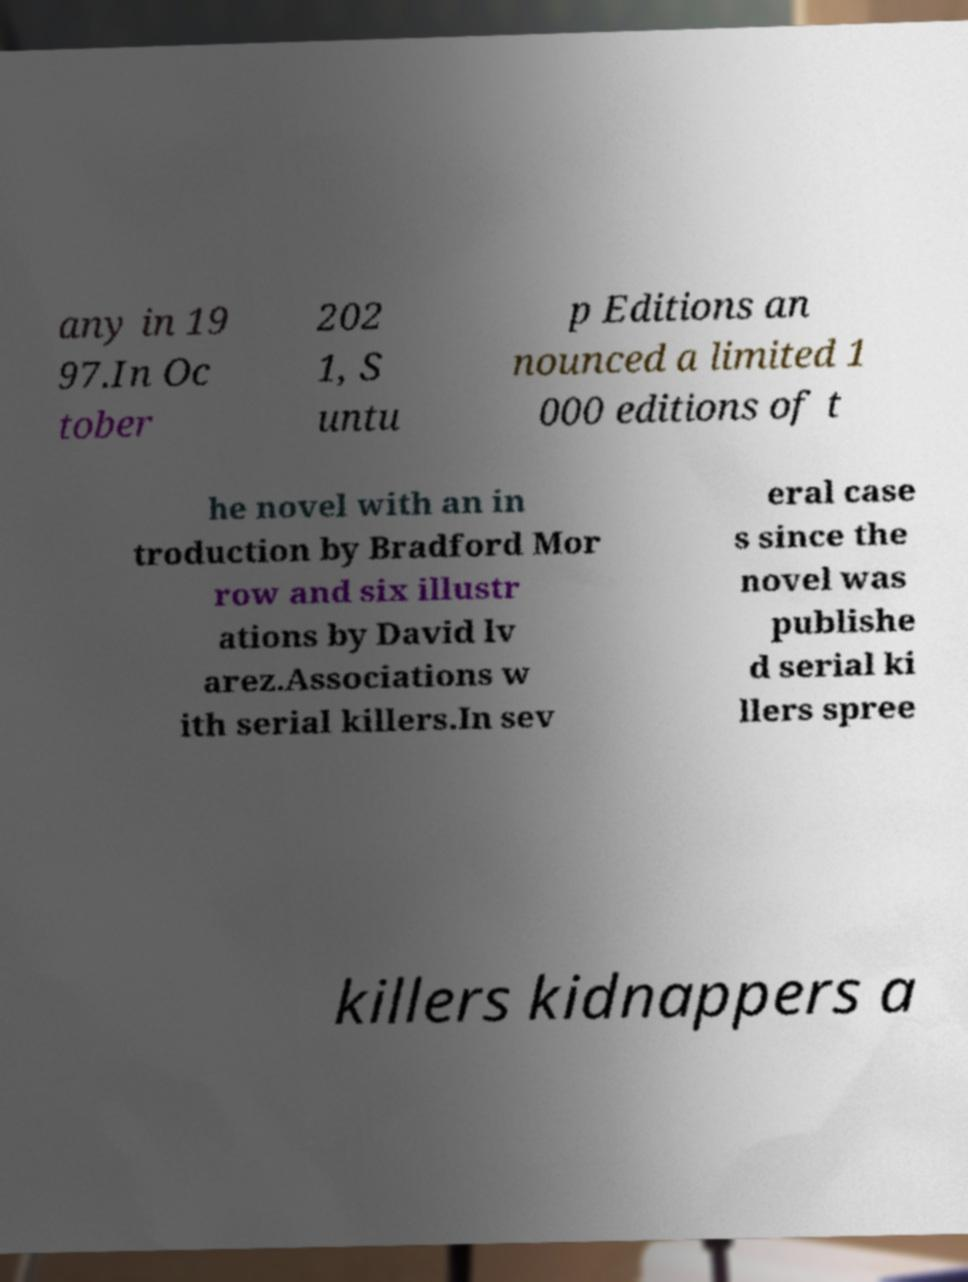What messages or text are displayed in this image? I need them in a readable, typed format. any in 19 97.In Oc tober 202 1, S untu p Editions an nounced a limited 1 000 editions of t he novel with an in troduction by Bradford Mor row and six illustr ations by David lv arez.Associations w ith serial killers.In sev eral case s since the novel was publishe d serial ki llers spree killers kidnappers a 